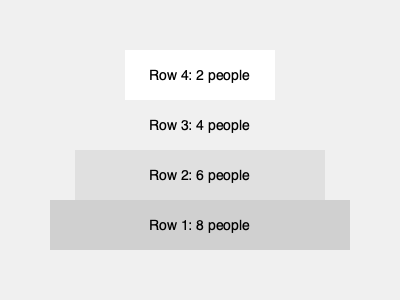In a family choir performance, you're arranging your extended family members in a tiered formation. Each row has two fewer people than the row below it, and the bottom row has 8 people. If you want to include all 20 family members, how many rows will the choir formation have? Let's approach this step-by-step:

1. We know that the bottom row has 8 people.
2. Each row above has 2 fewer people than the row below.
3. We need to fit all 20 family members.

Let's count the people in each row from bottom to top:

Row 1 (bottom): 8 people
Row 2: 6 people (8 - 2)
Row 3: 4 people (6 - 2)
Row 4: 2 people (4 - 2)

Now, let's sum up the total number of people:
$8 + 6 + 4 + 2 = 20$

We've accounted for all 20 family members using 4 rows.

To verify, we can use the arithmetic sequence formula:
$S_n = \frac{n}{2}(a_1 + a_n)$

Where:
$S_n$ is the sum (20 people)
$n$ is the number of rows (4)
$a_1$ is the first term (2 people in the top row)
$a_n$ is the last term (8 people in the bottom row)

$20 = \frac{4}{2}(2 + 8)$
$20 = 2(10)$
$20 = 20$

This confirms that 4 rows will accommodate all 20 family members in the described formation.
Answer: 4 rows 